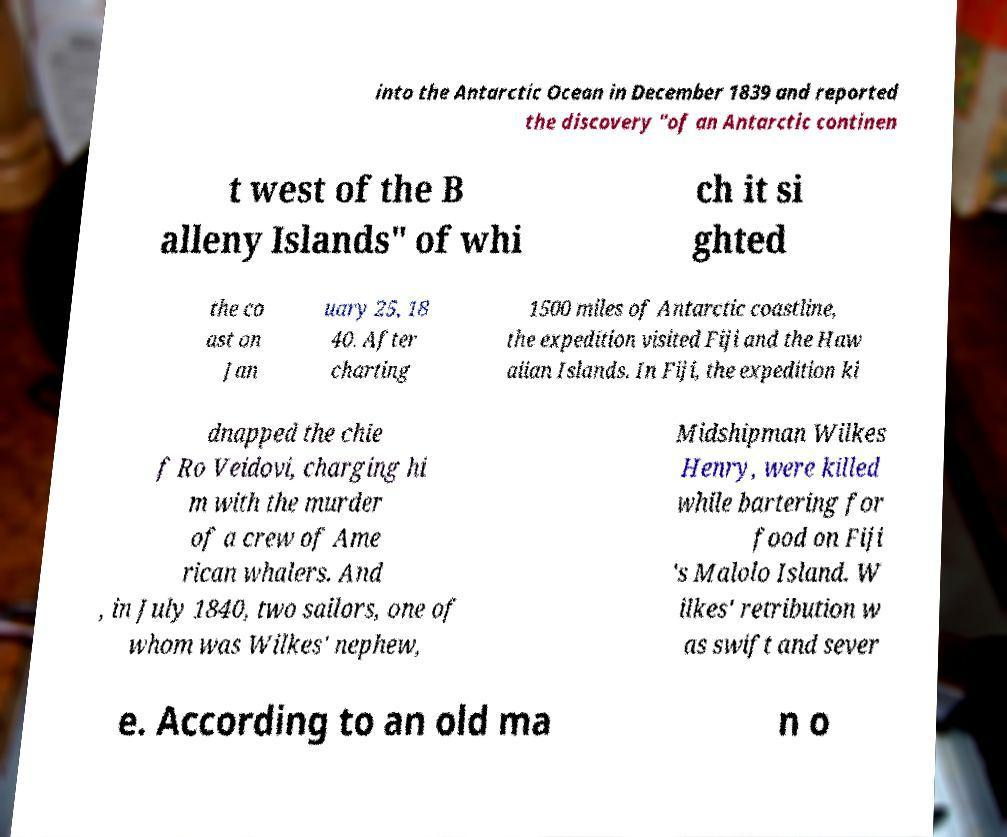Could you assist in decoding the text presented in this image and type it out clearly? into the Antarctic Ocean in December 1839 and reported the discovery "of an Antarctic continen t west of the B alleny Islands" of whi ch it si ghted the co ast on Jan uary 25, 18 40. After charting 1500 miles of Antarctic coastline, the expedition visited Fiji and the Haw aiian Islands. In Fiji, the expedition ki dnapped the chie f Ro Veidovi, charging hi m with the murder of a crew of Ame rican whalers. And , in July 1840, two sailors, one of whom was Wilkes' nephew, Midshipman Wilkes Henry, were killed while bartering for food on Fiji 's Malolo Island. W ilkes' retribution w as swift and sever e. According to an old ma n o 